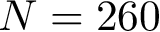<formula> <loc_0><loc_0><loc_500><loc_500>N = 2 6 0</formula> 